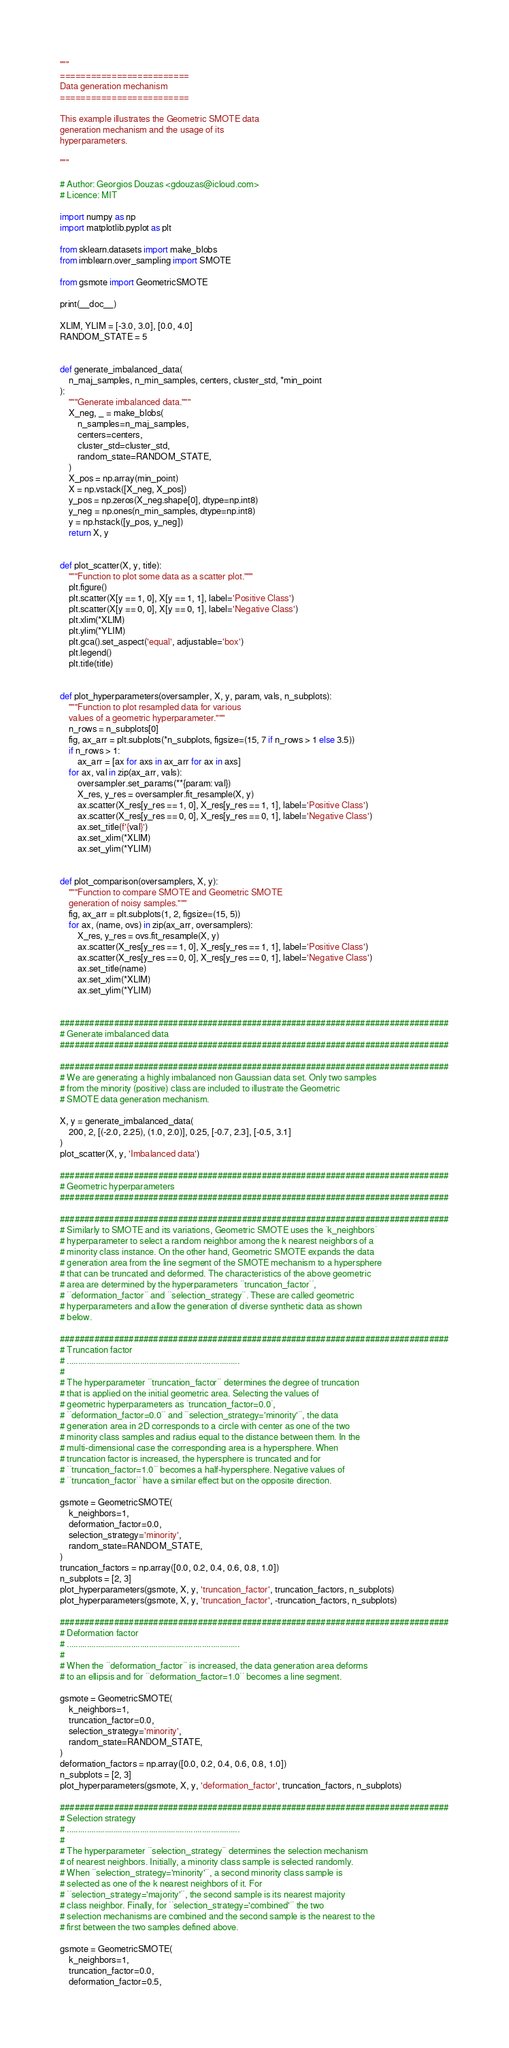<code> <loc_0><loc_0><loc_500><loc_500><_Python_>"""
=========================
Data generation mechanism
=========================

This example illustrates the Geometric SMOTE data 
generation mechanism and the usage of its 
hyperparameters.

"""

# Author: Georgios Douzas <gdouzas@icloud.com>
# Licence: MIT

import numpy as np
import matplotlib.pyplot as plt

from sklearn.datasets import make_blobs
from imblearn.over_sampling import SMOTE

from gsmote import GeometricSMOTE

print(__doc__)

XLIM, YLIM = [-3.0, 3.0], [0.0, 4.0]
RANDOM_STATE = 5


def generate_imbalanced_data(
    n_maj_samples, n_min_samples, centers, cluster_std, *min_point
):
    """Generate imbalanced data."""
    X_neg, _ = make_blobs(
        n_samples=n_maj_samples,
        centers=centers,
        cluster_std=cluster_std,
        random_state=RANDOM_STATE,
    )
    X_pos = np.array(min_point)
    X = np.vstack([X_neg, X_pos])
    y_pos = np.zeros(X_neg.shape[0], dtype=np.int8)
    y_neg = np.ones(n_min_samples, dtype=np.int8)
    y = np.hstack([y_pos, y_neg])
    return X, y


def plot_scatter(X, y, title):
    """Function to plot some data as a scatter plot."""
    plt.figure()
    plt.scatter(X[y == 1, 0], X[y == 1, 1], label='Positive Class')
    plt.scatter(X[y == 0, 0], X[y == 0, 1], label='Negative Class')
    plt.xlim(*XLIM)
    plt.ylim(*YLIM)
    plt.gca().set_aspect('equal', adjustable='box')
    plt.legend()
    plt.title(title)


def plot_hyperparameters(oversampler, X, y, param, vals, n_subplots):
    """Function to plot resampled data for various
    values of a geometric hyperparameter."""
    n_rows = n_subplots[0]
    fig, ax_arr = plt.subplots(*n_subplots, figsize=(15, 7 if n_rows > 1 else 3.5))
    if n_rows > 1:
        ax_arr = [ax for axs in ax_arr for ax in axs]
    for ax, val in zip(ax_arr, vals):
        oversampler.set_params(**{param: val})
        X_res, y_res = oversampler.fit_resample(X, y)
        ax.scatter(X_res[y_res == 1, 0], X_res[y_res == 1, 1], label='Positive Class')
        ax.scatter(X_res[y_res == 0, 0], X_res[y_res == 0, 1], label='Negative Class')
        ax.set_title(f'{val}')
        ax.set_xlim(*XLIM)
        ax.set_ylim(*YLIM)


def plot_comparison(oversamplers, X, y):
    """Function to compare SMOTE and Geometric SMOTE
    generation of noisy samples."""
    fig, ax_arr = plt.subplots(1, 2, figsize=(15, 5))
    for ax, (name, ovs) in zip(ax_arr, oversamplers):
        X_res, y_res = ovs.fit_resample(X, y)
        ax.scatter(X_res[y_res == 1, 0], X_res[y_res == 1, 1], label='Positive Class')
        ax.scatter(X_res[y_res == 0, 0], X_res[y_res == 0, 1], label='Negative Class')
        ax.set_title(name)
        ax.set_xlim(*XLIM)
        ax.set_ylim(*YLIM)


###############################################################################
# Generate imbalanced data
###############################################################################

###############################################################################
# We are generating a highly imbalanced non Gaussian data set. Only two samples
# from the minority (positive) class are included to illustrate the Geometric
# SMOTE data generation mechanism.

X, y = generate_imbalanced_data(
    200, 2, [(-2.0, 2.25), (1.0, 2.0)], 0.25, [-0.7, 2.3], [-0.5, 3.1]
)
plot_scatter(X, y, 'Imbalanced data')

###############################################################################
# Geometric hyperparameters
###############################################################################

###############################################################################
# Similarly to SMOTE and its variations, Geometric SMOTE uses the `k_neighbors`
# hyperparameter to select a random neighbor among the k nearest neighbors of a
# minority class instance. On the other hand, Geometric SMOTE expands the data
# generation area from the line segment of the SMOTE mechanism to a hypersphere
# that can be truncated and deformed. The characteristics of the above geometric
# area are determined by the hyperparameters ``truncation_factor``,
# ``deformation_factor`` and ``selection_strategy``. These are called geometric
# hyperparameters and allow the generation of diverse synthetic data as shown
# below.

###############################################################################
# Truncation factor
# ..............................................................................
#
# The hyperparameter ``truncation_factor`` determines the degree of truncation
# that is applied on the initial geometric area. Selecting the values of
# geometric hyperparameters as `truncation_factor=0.0`,
# ``deformation_factor=0.0`` and ``selection_strategy='minority'``, the data
# generation area in 2D corresponds to a circle with center as one of the two
# minority class samples and radius equal to the distance between them. In the
# multi-dimensional case the corresponding area is a hypersphere. When
# truncation factor is increased, the hypersphere is truncated and for
# ``truncation_factor=1.0`` becomes a half-hypersphere. Negative values of
# ``truncation_factor`` have a similar effect but on the opposite direction.

gsmote = GeometricSMOTE(
    k_neighbors=1,
    deformation_factor=0.0,
    selection_strategy='minority',
    random_state=RANDOM_STATE,
)
truncation_factors = np.array([0.0, 0.2, 0.4, 0.6, 0.8, 1.0])
n_subplots = [2, 3]
plot_hyperparameters(gsmote, X, y, 'truncation_factor', truncation_factors, n_subplots)
plot_hyperparameters(gsmote, X, y, 'truncation_factor', -truncation_factors, n_subplots)

###############################################################################
# Deformation factor
# ..............................................................................
#
# When the ``deformation_factor`` is increased, the data generation area deforms
# to an ellipsis and for ``deformation_factor=1.0`` becomes a line segment.

gsmote = GeometricSMOTE(
    k_neighbors=1,
    truncation_factor=0.0,
    selection_strategy='minority',
    random_state=RANDOM_STATE,
)
deformation_factors = np.array([0.0, 0.2, 0.4, 0.6, 0.8, 1.0])
n_subplots = [2, 3]
plot_hyperparameters(gsmote, X, y, 'deformation_factor', truncation_factors, n_subplots)

###############################################################################
# Selection strategy
# ..............................................................................
#
# The hyperparameter ``selection_strategy`` determines the selection mechanism
# of nearest neighbors. Initially, a minority class sample is selected randomly.
# When ``selection_strategy='minority'``, a second minority class sample is
# selected as one of the k nearest neighbors of it. For
# ``selection_strategy='majority'``, the second sample is its nearest majority
# class neighbor. Finally, for ``selection_strategy='combined'`` the two
# selection mechanisms are combined and the second sample is the nearest to the
# first between the two samples defined above.

gsmote = GeometricSMOTE(
    k_neighbors=1,
    truncation_factor=0.0,
    deformation_factor=0.5,</code> 